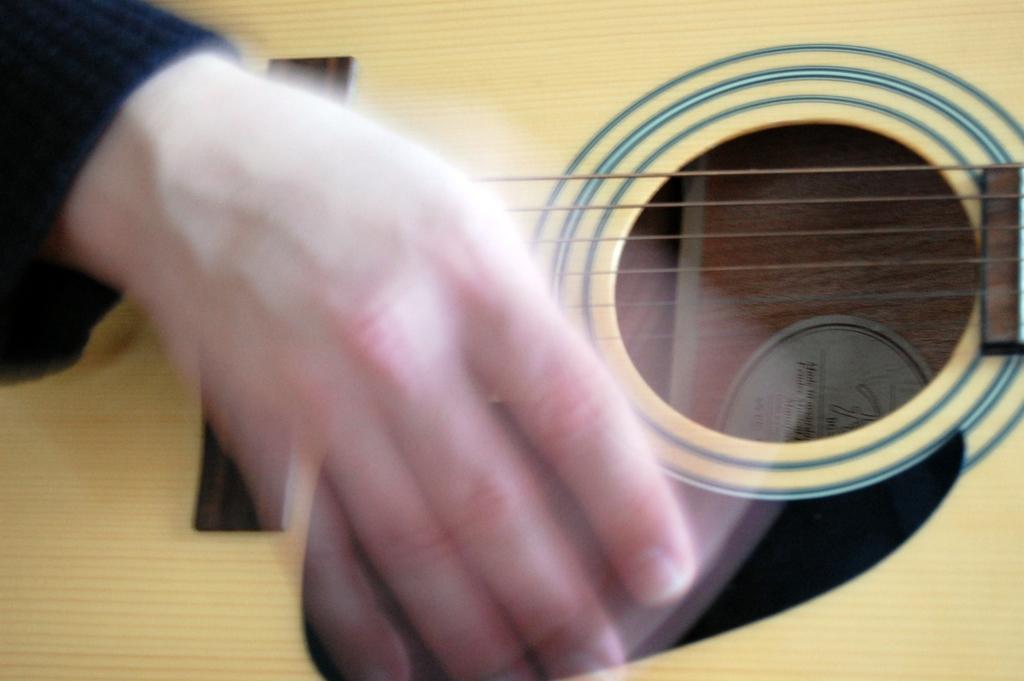Can you describe this image briefly? In the image there is a person's hand and a guitar. 